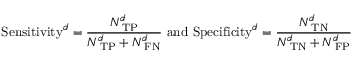<formula> <loc_0><loc_0><loc_500><loc_500>S e n s i t i v i t y ^ { \boldsymbol d } = \frac { N _ { T P } ^ { \boldsymbol d } } { N _ { T P } ^ { \boldsymbol d } + N _ { F N } ^ { \boldsymbol d } } a n d S p e c i f i c i t y ^ { \boldsymbol d } = \frac { N _ { T N } ^ { \boldsymbol d } } { N _ { T N } ^ { d } + N _ { F P } ^ { \boldsymbol d } }</formula> 